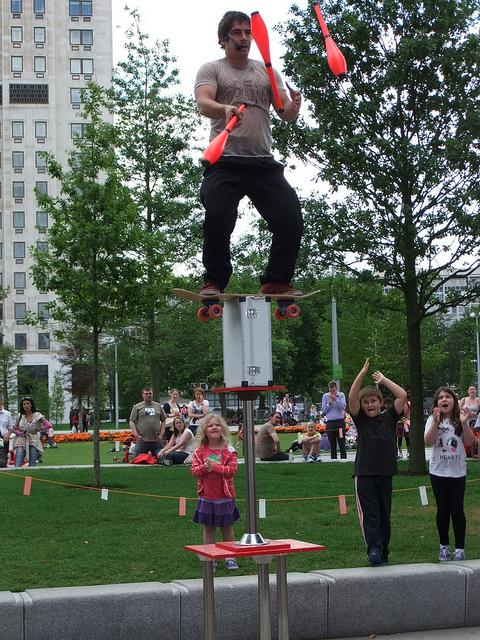How many pins are juggled up on top of the post by the man standing on the skateboard? three 